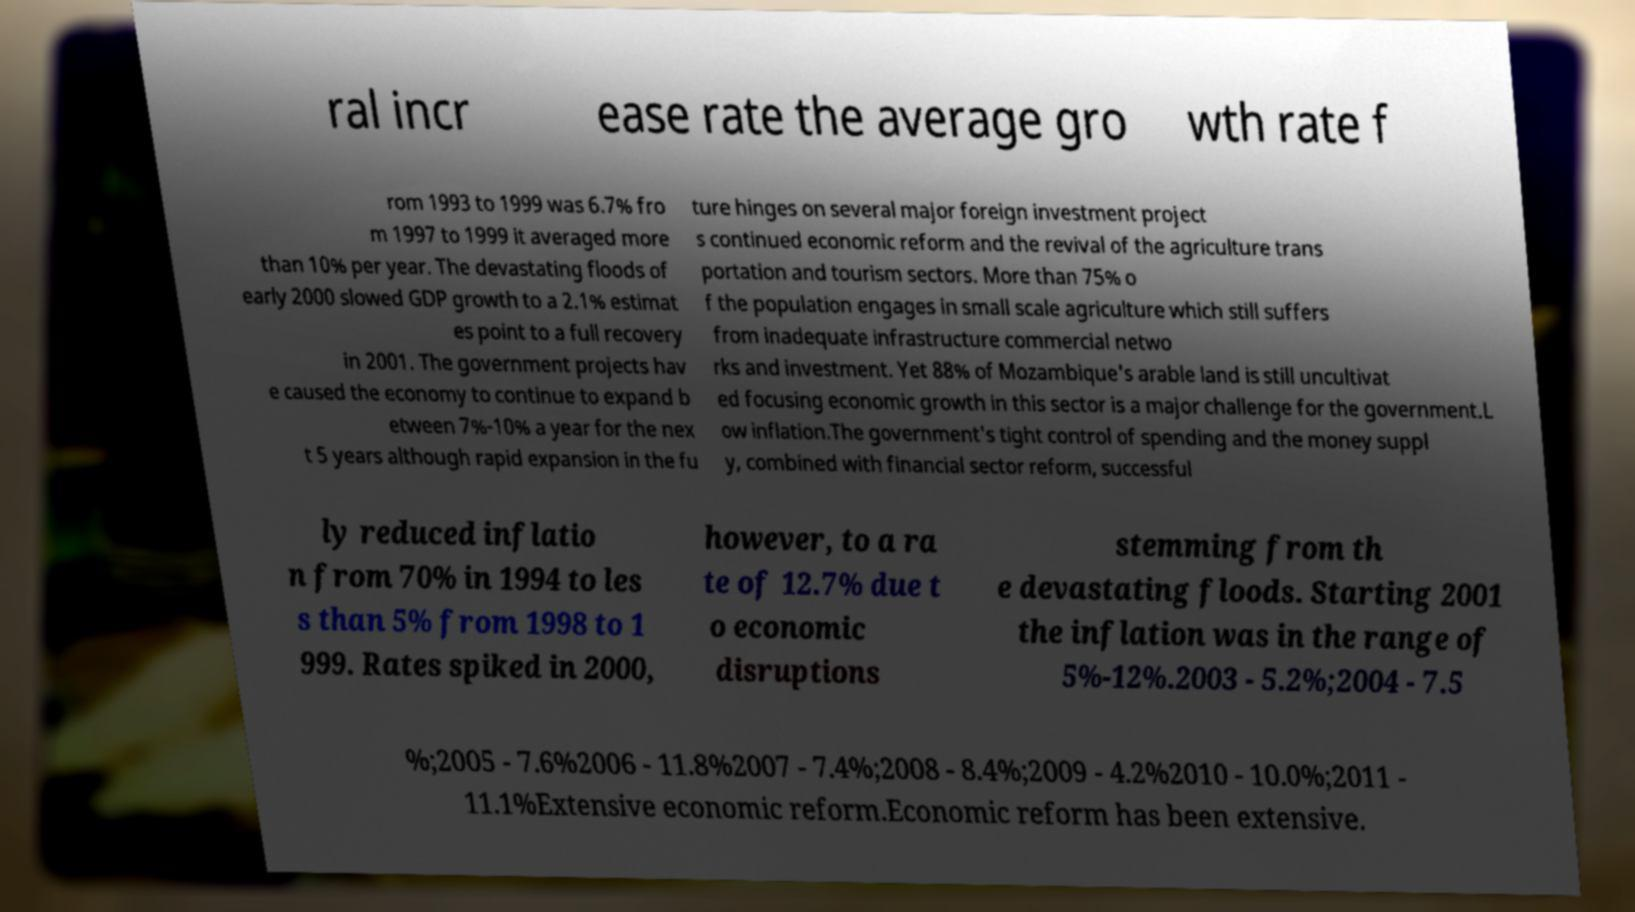For documentation purposes, I need the text within this image transcribed. Could you provide that? ral incr ease rate the average gro wth rate f rom 1993 to 1999 was 6.7% fro m 1997 to 1999 it averaged more than 10% per year. The devastating floods of early 2000 slowed GDP growth to a 2.1% estimat es point to a full recovery in 2001. The government projects hav e caused the economy to continue to expand b etween 7%-10% a year for the nex t 5 years although rapid expansion in the fu ture hinges on several major foreign investment project s continued economic reform and the revival of the agriculture trans portation and tourism sectors. More than 75% o f the population engages in small scale agriculture which still suffers from inadequate infrastructure commercial netwo rks and investment. Yet 88% of Mozambique's arable land is still uncultivat ed focusing economic growth in this sector is a major challenge for the government.L ow inflation.The government's tight control of spending and the money suppl y, combined with financial sector reform, successful ly reduced inflatio n from 70% in 1994 to les s than 5% from 1998 to 1 999. Rates spiked in 2000, however, to a ra te of 12.7% due t o economic disruptions stemming from th e devastating floods. Starting 2001 the inflation was in the range of 5%-12%.2003 - 5.2%;2004 - 7.5 %;2005 - 7.6%2006 - 11.8%2007 - 7.4%;2008 - 8.4%;2009 - 4.2%2010 - 10.0%;2011 - 11.1%Extensive economic reform.Economic reform has been extensive. 